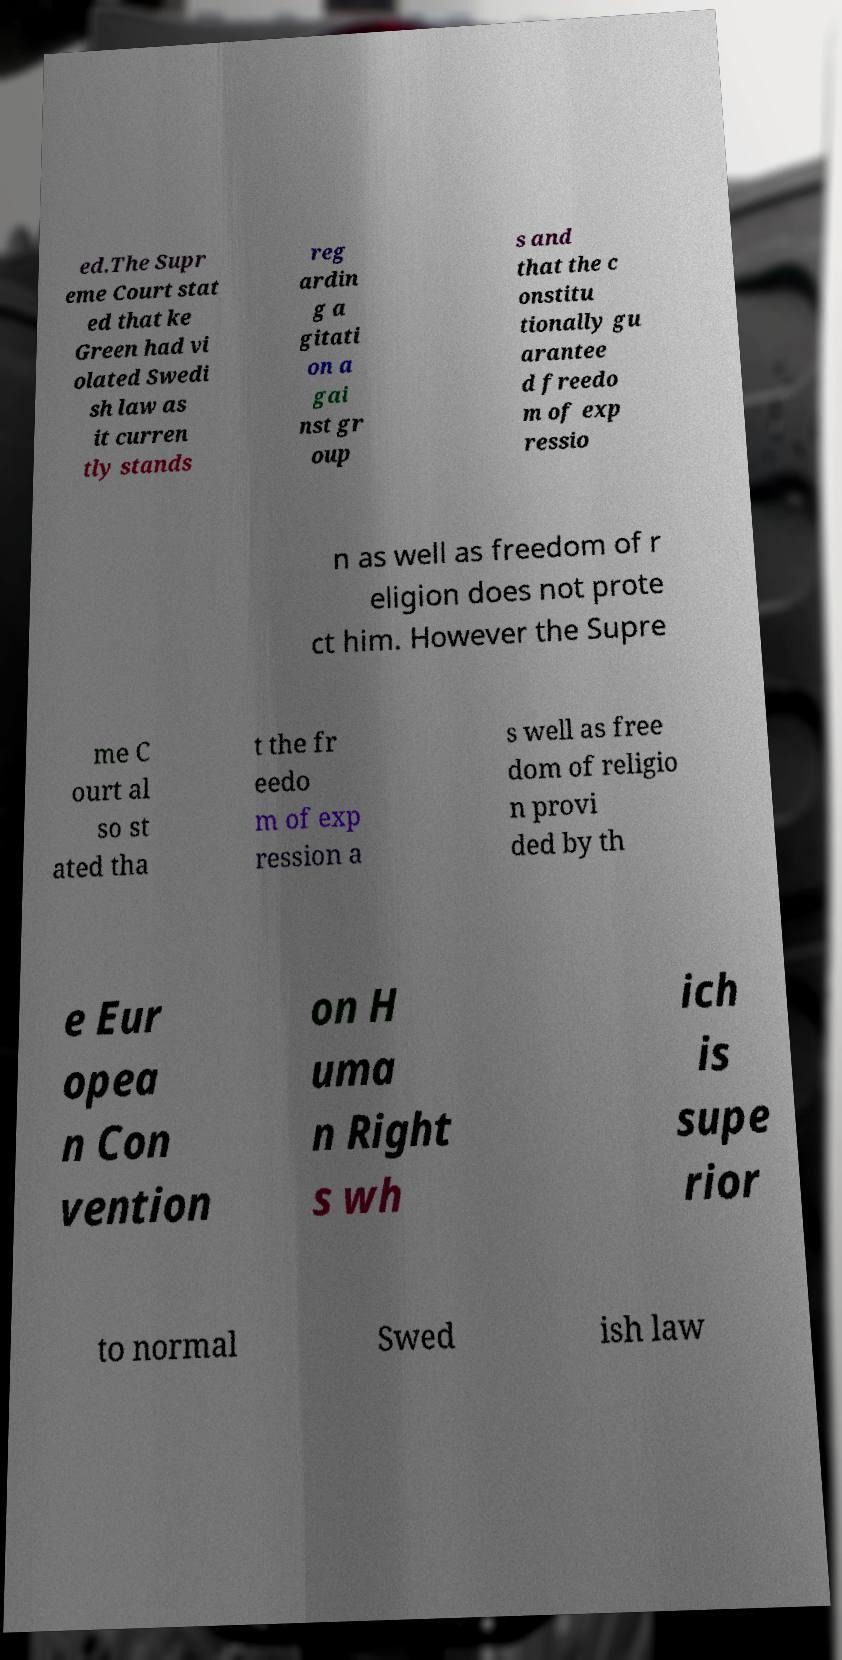Please identify and transcribe the text found in this image. ed.The Supr eme Court stat ed that ke Green had vi olated Swedi sh law as it curren tly stands reg ardin g a gitati on a gai nst gr oup s and that the c onstitu tionally gu arantee d freedo m of exp ressio n as well as freedom of r eligion does not prote ct him. However the Supre me C ourt al so st ated tha t the fr eedo m of exp ression a s well as free dom of religio n provi ded by th e Eur opea n Con vention on H uma n Right s wh ich is supe rior to normal Swed ish law 